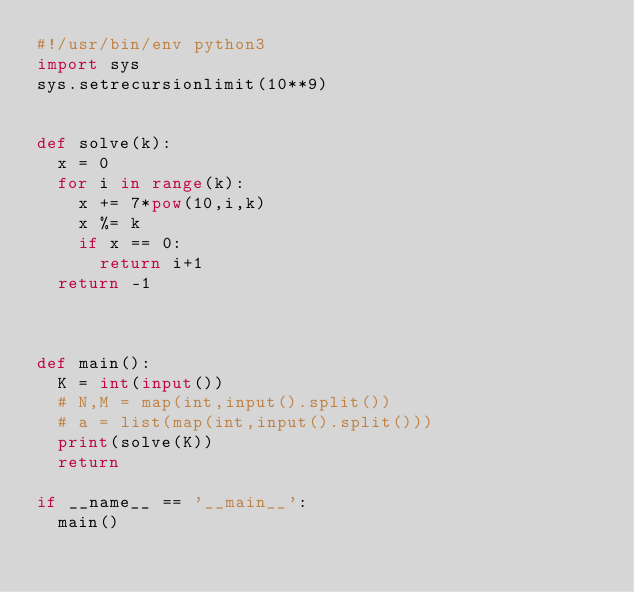Convert code to text. <code><loc_0><loc_0><loc_500><loc_500><_Python_>#!/usr/bin/env python3
import sys
sys.setrecursionlimit(10**9)


def solve(k):
  x = 0
  for i in range(k):
    x += 7*pow(10,i,k)
    x %= k
    if x == 0:
      return i+1
  return -1



def main():
  K = int(input())
  # N,M = map(int,input().split())
  # a = list(map(int,input().split()))
  print(solve(K))
  return

if __name__ == '__main__':
  main()
</code> 